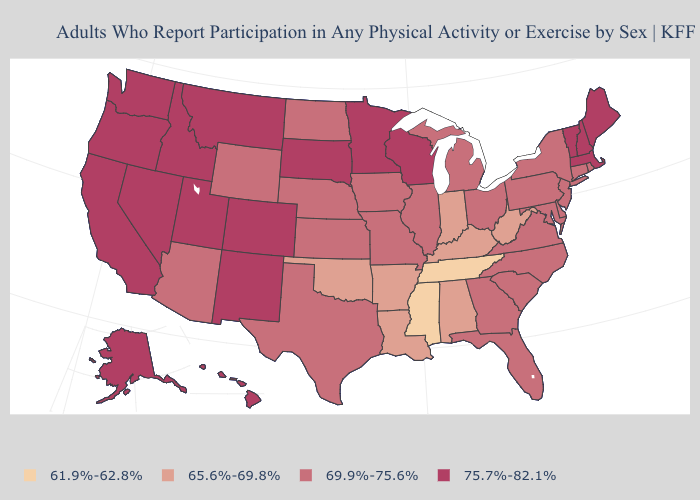How many symbols are there in the legend?
Keep it brief. 4. Which states hav the highest value in the South?
Give a very brief answer. Delaware, Florida, Georgia, Maryland, North Carolina, South Carolina, Texas, Virginia. Name the states that have a value in the range 75.7%-82.1%?
Answer briefly. Alaska, California, Colorado, Hawaii, Idaho, Maine, Massachusetts, Minnesota, Montana, Nevada, New Hampshire, New Mexico, Oregon, South Dakota, Utah, Vermont, Washington, Wisconsin. What is the value of North Carolina?
Short answer required. 69.9%-75.6%. What is the value of Oregon?
Be succinct. 75.7%-82.1%. What is the value of Maine?
Short answer required. 75.7%-82.1%. Among the states that border North Carolina , which have the highest value?
Be succinct. Georgia, South Carolina, Virginia. Name the states that have a value in the range 61.9%-62.8%?
Concise answer only. Mississippi, Tennessee. Does the map have missing data?
Concise answer only. No. Which states have the lowest value in the USA?
Be succinct. Mississippi, Tennessee. What is the value of West Virginia?
Short answer required. 65.6%-69.8%. Name the states that have a value in the range 61.9%-62.8%?
Answer briefly. Mississippi, Tennessee. What is the value of Connecticut?
Keep it brief. 69.9%-75.6%. What is the value of Vermont?
Concise answer only. 75.7%-82.1%. Name the states that have a value in the range 61.9%-62.8%?
Answer briefly. Mississippi, Tennessee. 